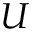<formula> <loc_0><loc_0><loc_500><loc_500>U</formula> 